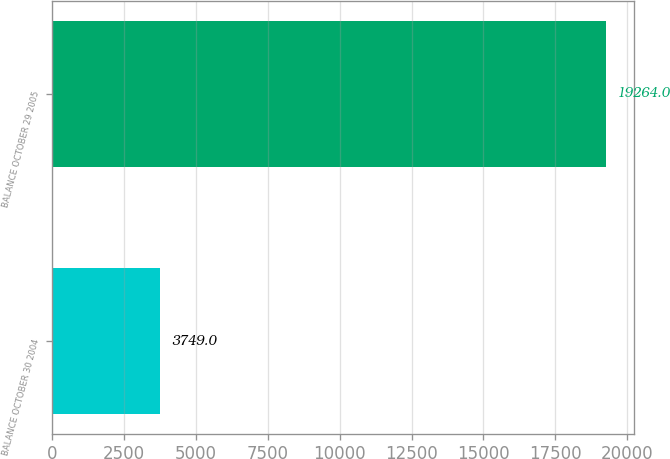Convert chart. <chart><loc_0><loc_0><loc_500><loc_500><bar_chart><fcel>BALANCE OCTOBER 30 2004<fcel>BALANCE OCTOBER 29 2005<nl><fcel>3749<fcel>19264<nl></chart> 